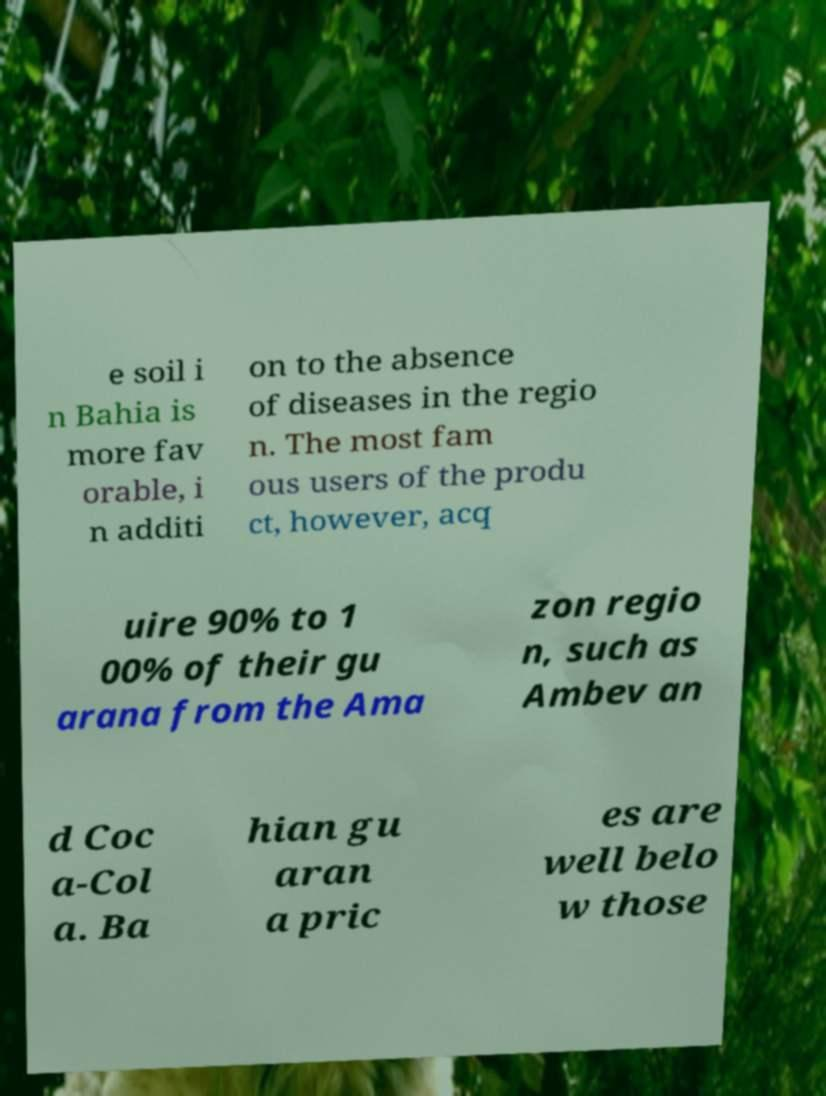Could you assist in decoding the text presented in this image and type it out clearly? e soil i n Bahia is more fav orable, i n additi on to the absence of diseases in the regio n. The most fam ous users of the produ ct, however, acq uire 90% to 1 00% of their gu arana from the Ama zon regio n, such as Ambev an d Coc a-Col a. Ba hian gu aran a pric es are well belo w those 